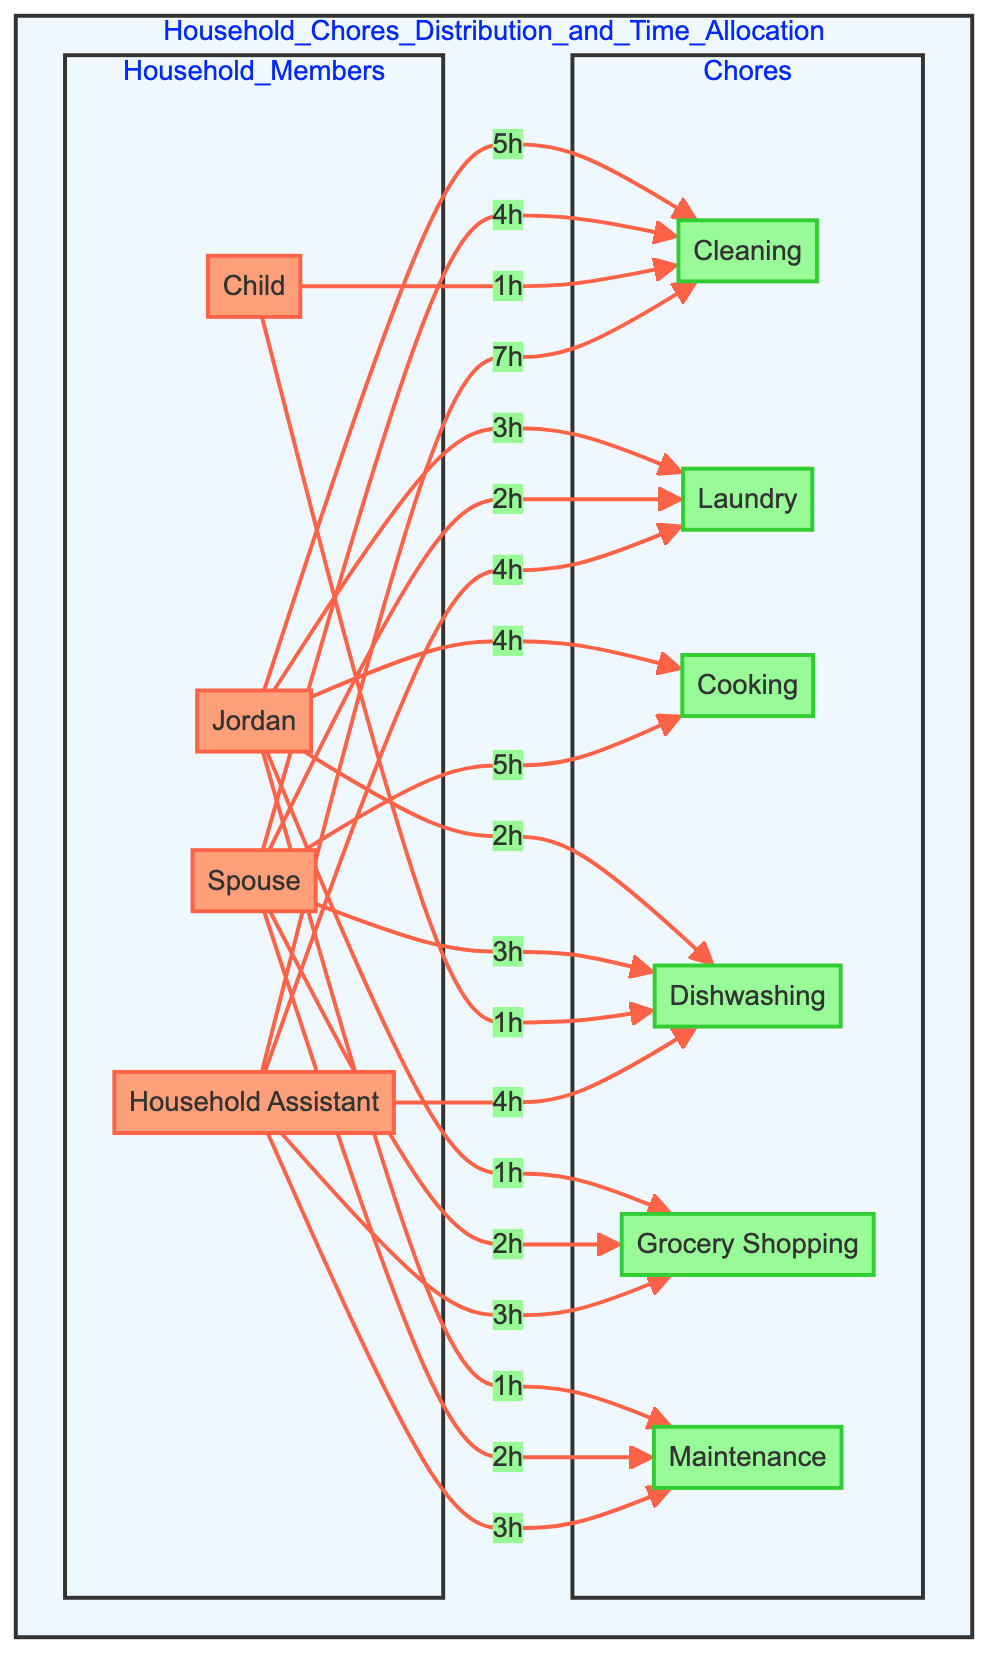What is the total time Jordan spends on cleaning? The diagram shows that Jordan spends 5 hours on cleaning. This is directly indicated by the arrow leading from Jordan to Cleaning, which is marked with "5h".
Answer: 5 hours Who spends the most time on cooking? By reviewing the cooking times for all household members, Jordan spends 4 hours, the Spouse spends 5 hours, the Child spends 0 hours, and the Household Assistant spends 0 hours. The highest value is clearly 5 hours for the Spouse.
Answer: Spouse What is the total time spent on laundry by all members? First, I add the laundry time for each member: Jordan - 3 hours, Spouse - 2 hours, Child - 0 hours, Household Assistant - 4 hours. Adding these together gives 3 + 2 + 0 + 4 = 9 hours total for laundry.
Answer: 9 hours Which member has no responsibilities in cooking? By examining the cooking times for each member: Jordan - 4 hours, Spouse - 5 hours, Child - 0 hours, Household Assistant - 0 hours. Both the Child and the Household Assistant have 0 hours assigned to cooking, but since the question asks for any member, I can say Child or Household Assistant.
Answer: Child What is the combined total time spent on grocery shopping by all members? The grocery shopping times are: Jordan - 1 hour, Spouse - 2 hours, Child - 0 hours, Household Assistant - 3 hours. Adding these gives 1 + 2 + 0 + 3 = 6 hours total for grocery shopping.
Answer: 6 hours Which chore takes the most time overall? To find out the chore with the most time, I will sum the time allocated to each chore: For cleaning, the total is 5 + 4 + 1 + 7 = 17 hours; for laundry, it's 3 + 2 + 0 + 4 = 9 hours; cooking totals to 4 + 5 + 0 + 0 = 9 hours; dishwashing totals 2 + 3 + 1 + 4 = 10 hours; grocery shopping totals 1 + 2 + 0 + 3 = 6 hours; maintenance totals 1 + 2 + 0 + 3 = 6 hours. The highest total is for cleaning at 17 hours.
Answer: Cleaning How many chores are listed in the diagram? The diagram lists the following chores: Cleaning, Laundry, Cooking, Dishwashing, Grocery Shopping, and Maintenance, which totals to 6 unique chores.
Answer: 6 Which member shared the responsibility of dishwashing with Jordan? Looking at the dishwashing times, Jordan spends 2 hours on dishwashing, while the Spouse spends 3 hours, the Child spends 1 hour, and the Household Assistant spends 4 hours. Thus, the members who also perform dishwashing responsibilities are the Spouse, Child, and Household Assistant.
Answer: Spouse, Child, Household Assistant 